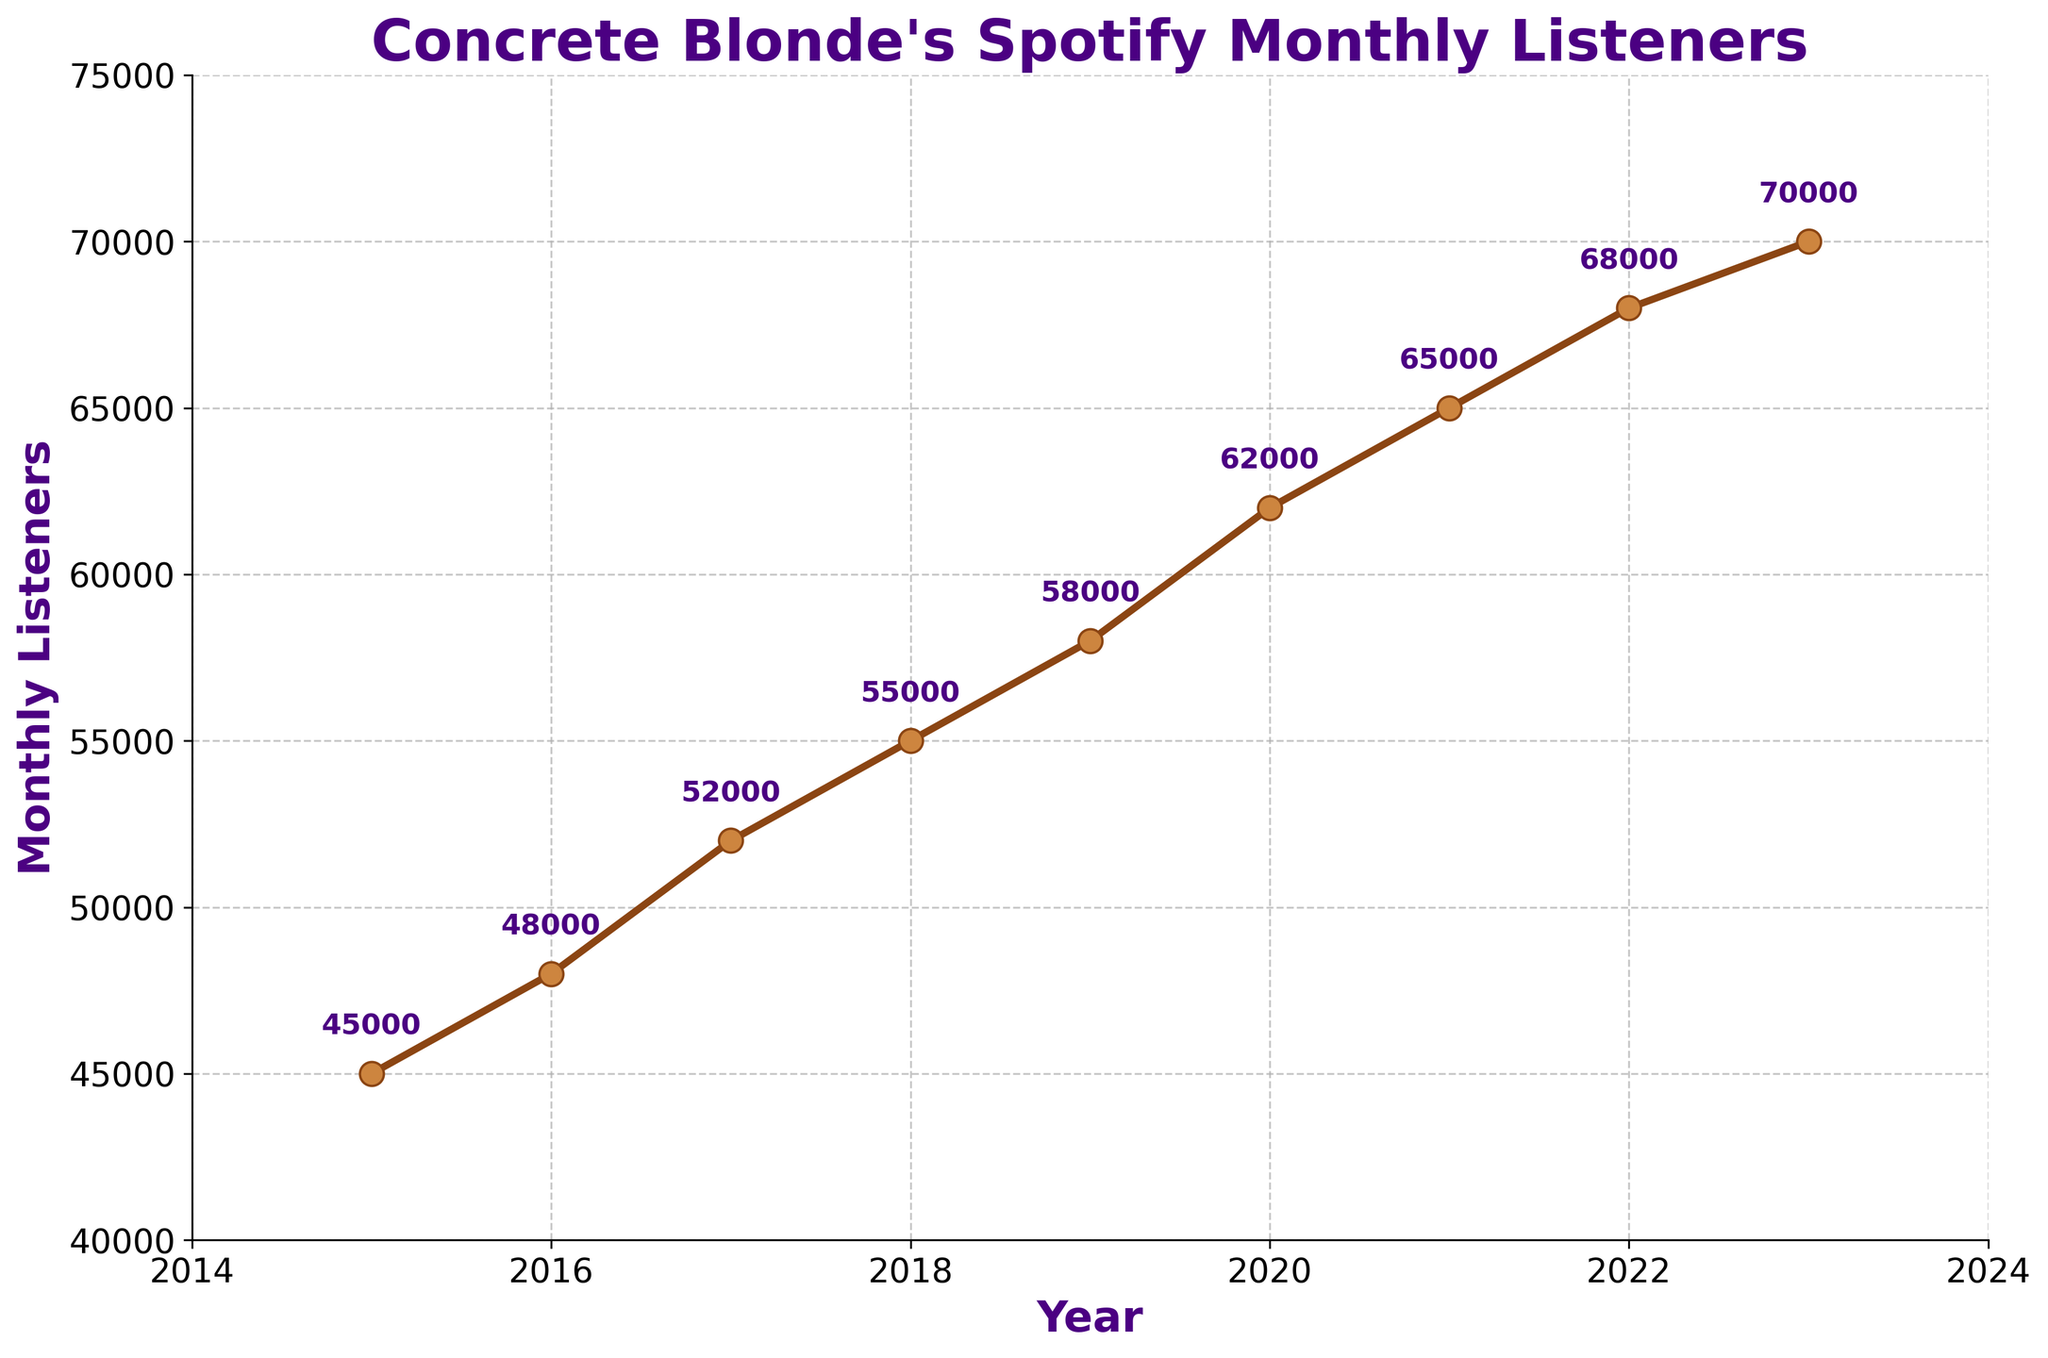Which year had the highest number of monthly listeners for Concrete Blonde? The line chart shows 2023 having the highest point on the y-axis representing monthly listeners.
Answer: 2023 How many more monthly listeners did Concrete Blonde have in 2023 compared to 2015? In 2015 they had 45,000 listeners and in 2023 they had 70,000. The difference is 70,000 - 45,000 = 25,000.
Answer: 25,000 What was the average number of monthly listeners from 2015 to 2018? The data points from 2015 to 2018 are 45,000, 48,000, 52,000, and 55,000. Adding them gives 45,000 + 48,000 + 52,000 + 55,000 = 200,000. Dividing by 4 years gives an average of 200,000 / 4 = 50,000.
Answer: 50,000 By how much did the monthly listeners increase from 2017 to 2020? In 2017, the listeners were 52,000 and in 2020 they were 62,000. The increase is 62,000 - 52,000 = 10,000.
Answer: 10,000 Which year witnessed the smallest increase in monthly listeners compared to the previous year? Comparing the increments year-over-year: 2015-2016: 3,000; 2016-2017: 4,000; 2017-2018: 3,000; 2018-2019: 3,000; 2019-2020: 4,000; 2020-2021: 3,000; 2021-2022: 3,000; 2022-2023: 2,000. The smallest increase is from 2022 to 2023.
Answer: 2022-2023 What is the percentage increase in monthly listeners from 2015 to 2023? The increase from 2015 to 2023 is 70,000 - 45,000 = 25,000. The percentage increase is (25,000 / 45,000) * 100 = 55.56%.
Answer: 55.56% How many years did it take for Concrete Blonde's monthly listeners to increase from 50,000 to 60,000? Monthly listeners reached 50,000 in 2017 and 60,000 in 2020. It took 2020 - 2017 = 3 years.
Answer: 3 years 